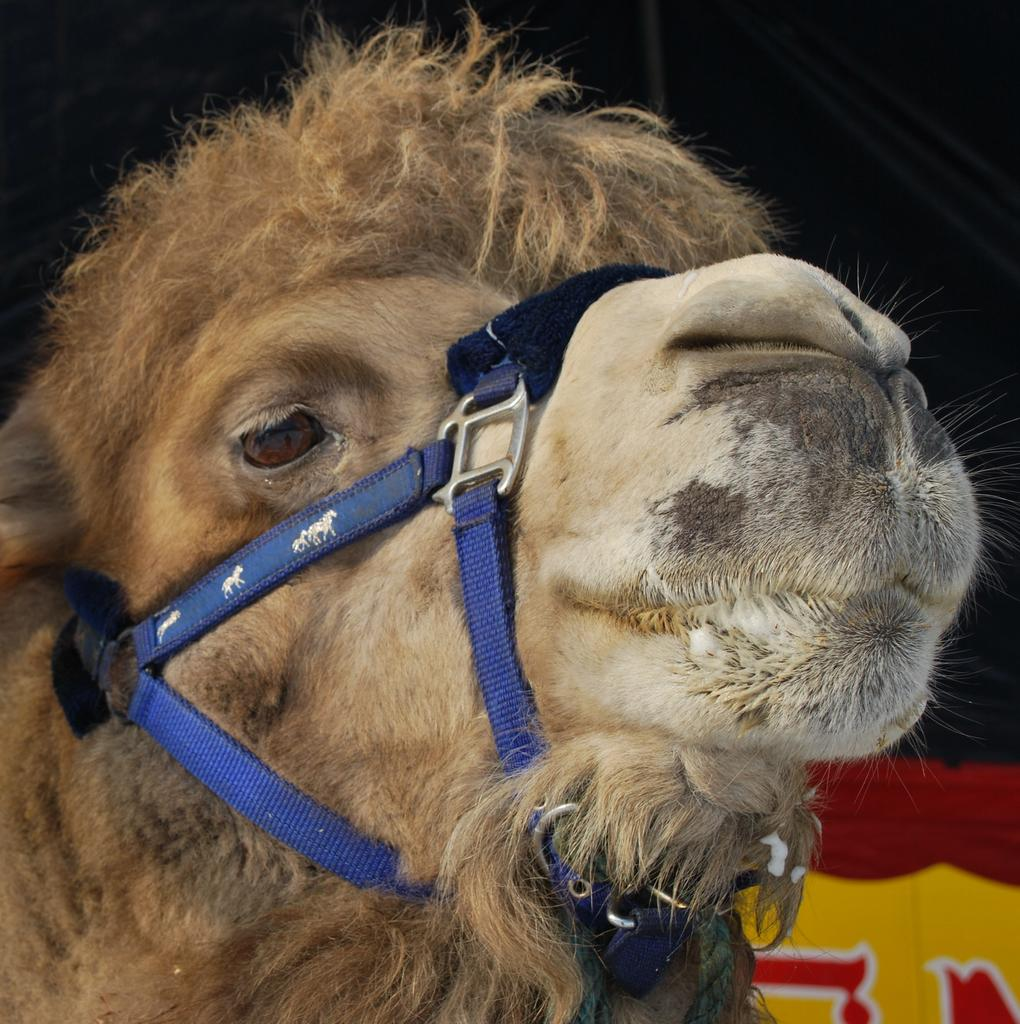What type of living creature is present in the image? There is an animal in the image. Can you describe the fog in the image? There is no fog present in the image; it only features an animal. Is the animal driving a vehicle in the image? There is no vehicle or driving activity depicted in the image; it only features an animal. 